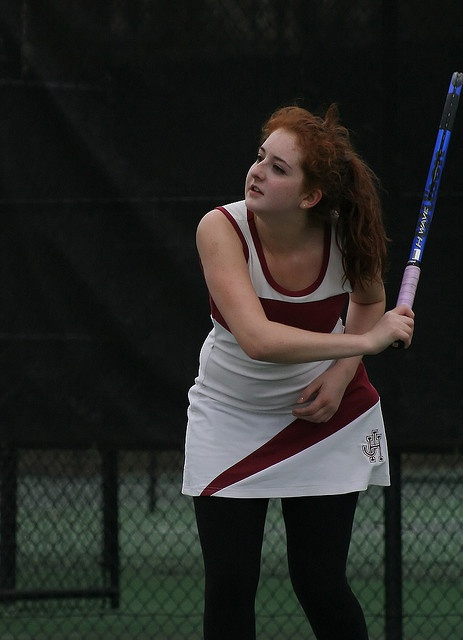Describe the objects in this image and their specific colors. I can see people in black, darkgray, gray, and maroon tones and tennis racket in black, darkgray, navy, and darkblue tones in this image. 